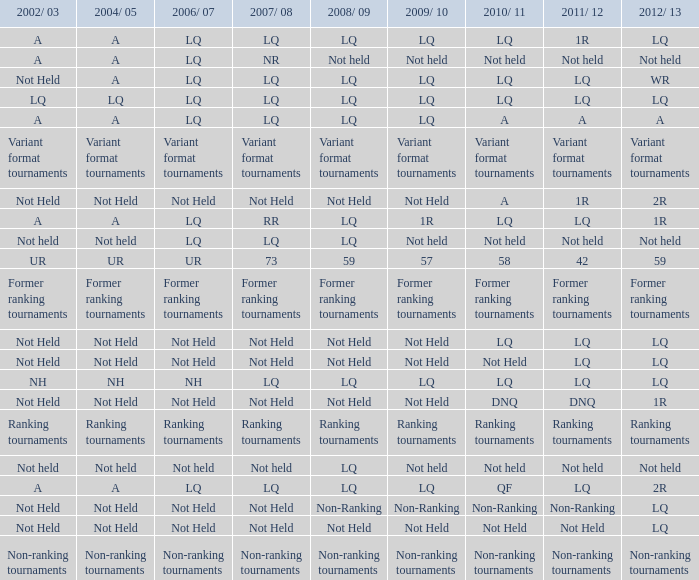Name the 2009/10 with 2011/12 of a LQ. 